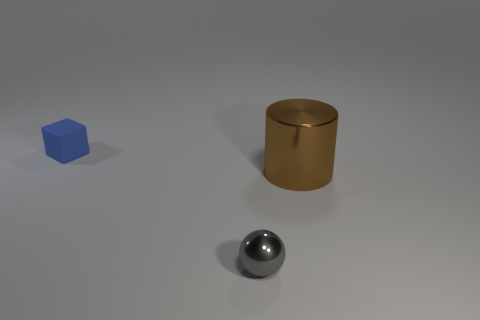Does the small object that is to the right of the tiny blue block have the same material as the thing right of the tiny shiny ball?
Your answer should be compact. Yes. What is the color of the metallic ball that is the same size as the cube?
Offer a terse response. Gray. Is there any other thing of the same color as the big shiny thing?
Your response must be concise. No. There is a metal object that is in front of the metal thing that is to the right of the small object that is on the right side of the blue block; how big is it?
Give a very brief answer. Small. There is a thing that is on the left side of the large metallic cylinder and in front of the small cube; what color is it?
Make the answer very short. Gray. There is a thing in front of the large brown shiny object; what size is it?
Your response must be concise. Small. How many gray balls are made of the same material as the cylinder?
Your answer should be very brief. 1. Is the shape of the tiny object in front of the brown metal cylinder the same as  the large brown object?
Give a very brief answer. No. What color is the tiny object that is the same material as the big object?
Your answer should be very brief. Gray. There is a matte thing on the left side of the metal object right of the tiny gray metal object; is there a gray shiny ball that is behind it?
Keep it short and to the point. No. 